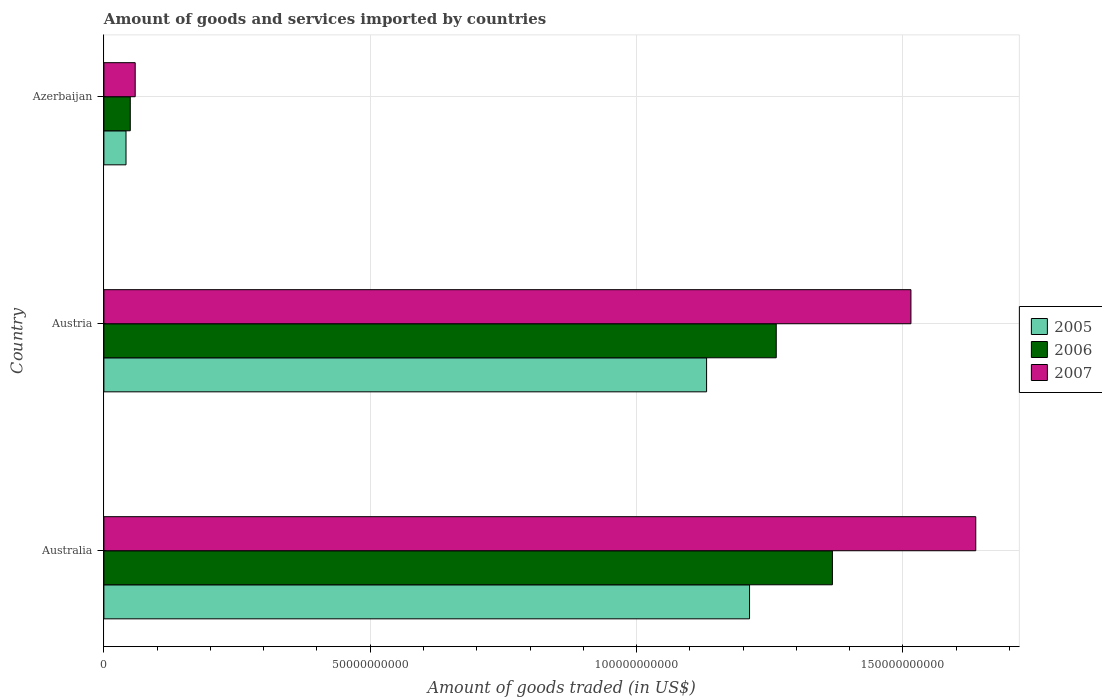How many different coloured bars are there?
Provide a short and direct response. 3. Are the number of bars per tick equal to the number of legend labels?
Make the answer very short. Yes. Are the number of bars on each tick of the Y-axis equal?
Provide a succinct answer. Yes. How many bars are there on the 3rd tick from the top?
Your answer should be compact. 3. What is the label of the 1st group of bars from the top?
Make the answer very short. Azerbaijan. What is the total amount of goods and services imported in 2007 in Australia?
Provide a succinct answer. 1.64e+11. Across all countries, what is the maximum total amount of goods and services imported in 2005?
Make the answer very short. 1.21e+11. Across all countries, what is the minimum total amount of goods and services imported in 2007?
Your answer should be compact. 5.88e+09. In which country was the total amount of goods and services imported in 2005 minimum?
Your answer should be compact. Azerbaijan. What is the total total amount of goods and services imported in 2005 in the graph?
Ensure brevity in your answer.  2.39e+11. What is the difference between the total amount of goods and services imported in 2007 in Austria and that in Azerbaijan?
Offer a very short reply. 1.46e+11. What is the difference between the total amount of goods and services imported in 2006 in Azerbaijan and the total amount of goods and services imported in 2005 in Austria?
Make the answer very short. -1.08e+11. What is the average total amount of goods and services imported in 2005 per country?
Provide a succinct answer. 7.95e+1. What is the difference between the total amount of goods and services imported in 2006 and total amount of goods and services imported in 2005 in Austria?
Ensure brevity in your answer.  1.31e+1. In how many countries, is the total amount of goods and services imported in 2005 greater than 110000000000 US$?
Keep it short and to the point. 2. What is the ratio of the total amount of goods and services imported in 2005 in Austria to that in Azerbaijan?
Your answer should be compact. 27.25. Is the total amount of goods and services imported in 2005 in Austria less than that in Azerbaijan?
Offer a terse response. No. Is the difference between the total amount of goods and services imported in 2006 in Austria and Azerbaijan greater than the difference between the total amount of goods and services imported in 2005 in Austria and Azerbaijan?
Your answer should be compact. Yes. What is the difference between the highest and the second highest total amount of goods and services imported in 2005?
Make the answer very short. 8.06e+09. What is the difference between the highest and the lowest total amount of goods and services imported in 2005?
Offer a terse response. 1.17e+11. Is the sum of the total amount of goods and services imported in 2005 in Austria and Azerbaijan greater than the maximum total amount of goods and services imported in 2006 across all countries?
Give a very brief answer. No. What does the 2nd bar from the bottom in Australia represents?
Give a very brief answer. 2006. Is it the case that in every country, the sum of the total amount of goods and services imported in 2006 and total amount of goods and services imported in 2005 is greater than the total amount of goods and services imported in 2007?
Provide a succinct answer. Yes. How many countries are there in the graph?
Provide a short and direct response. 3. What is the difference between two consecutive major ticks on the X-axis?
Keep it short and to the point. 5.00e+1. Does the graph contain any zero values?
Give a very brief answer. No. Does the graph contain grids?
Your answer should be very brief. Yes. Where does the legend appear in the graph?
Your response must be concise. Center right. How many legend labels are there?
Provide a short and direct response. 3. What is the title of the graph?
Your answer should be very brief. Amount of goods and services imported by countries. Does "1976" appear as one of the legend labels in the graph?
Your answer should be compact. No. What is the label or title of the X-axis?
Offer a very short reply. Amount of goods traded (in US$). What is the Amount of goods traded (in US$) in 2005 in Australia?
Give a very brief answer. 1.21e+11. What is the Amount of goods traded (in US$) in 2006 in Australia?
Offer a very short reply. 1.37e+11. What is the Amount of goods traded (in US$) in 2007 in Australia?
Your answer should be very brief. 1.64e+11. What is the Amount of goods traded (in US$) of 2005 in Austria?
Make the answer very short. 1.13e+11. What is the Amount of goods traded (in US$) in 2006 in Austria?
Your response must be concise. 1.26e+11. What is the Amount of goods traded (in US$) of 2007 in Austria?
Your response must be concise. 1.52e+11. What is the Amount of goods traded (in US$) in 2005 in Azerbaijan?
Make the answer very short. 4.15e+09. What is the Amount of goods traded (in US$) in 2006 in Azerbaijan?
Give a very brief answer. 4.95e+09. What is the Amount of goods traded (in US$) of 2007 in Azerbaijan?
Offer a very short reply. 5.88e+09. Across all countries, what is the maximum Amount of goods traded (in US$) in 2005?
Offer a terse response. 1.21e+11. Across all countries, what is the maximum Amount of goods traded (in US$) of 2006?
Ensure brevity in your answer.  1.37e+11. Across all countries, what is the maximum Amount of goods traded (in US$) of 2007?
Offer a very short reply. 1.64e+11. Across all countries, what is the minimum Amount of goods traded (in US$) in 2005?
Offer a very short reply. 4.15e+09. Across all countries, what is the minimum Amount of goods traded (in US$) of 2006?
Make the answer very short. 4.95e+09. Across all countries, what is the minimum Amount of goods traded (in US$) of 2007?
Offer a terse response. 5.88e+09. What is the total Amount of goods traded (in US$) of 2005 in the graph?
Provide a succinct answer. 2.39e+11. What is the total Amount of goods traded (in US$) of 2006 in the graph?
Your response must be concise. 2.68e+11. What is the total Amount of goods traded (in US$) in 2007 in the graph?
Provide a succinct answer. 3.21e+11. What is the difference between the Amount of goods traded (in US$) in 2005 in Australia and that in Austria?
Keep it short and to the point. 8.06e+09. What is the difference between the Amount of goods traded (in US$) in 2006 in Australia and that in Austria?
Your response must be concise. 1.05e+1. What is the difference between the Amount of goods traded (in US$) of 2007 in Australia and that in Austria?
Your answer should be very brief. 1.22e+1. What is the difference between the Amount of goods traded (in US$) of 2005 in Australia and that in Azerbaijan?
Provide a succinct answer. 1.17e+11. What is the difference between the Amount of goods traded (in US$) of 2006 in Australia and that in Azerbaijan?
Keep it short and to the point. 1.32e+11. What is the difference between the Amount of goods traded (in US$) of 2007 in Australia and that in Azerbaijan?
Offer a terse response. 1.58e+11. What is the difference between the Amount of goods traded (in US$) of 2005 in Austria and that in Azerbaijan?
Your response must be concise. 1.09e+11. What is the difference between the Amount of goods traded (in US$) of 2006 in Austria and that in Azerbaijan?
Offer a very short reply. 1.21e+11. What is the difference between the Amount of goods traded (in US$) in 2007 in Austria and that in Azerbaijan?
Keep it short and to the point. 1.46e+11. What is the difference between the Amount of goods traded (in US$) in 2005 in Australia and the Amount of goods traded (in US$) in 2006 in Austria?
Offer a very short reply. -5.01e+09. What is the difference between the Amount of goods traded (in US$) in 2005 in Australia and the Amount of goods traded (in US$) in 2007 in Austria?
Keep it short and to the point. -3.03e+1. What is the difference between the Amount of goods traded (in US$) in 2006 in Australia and the Amount of goods traded (in US$) in 2007 in Austria?
Your answer should be very brief. -1.47e+1. What is the difference between the Amount of goods traded (in US$) of 2005 in Australia and the Amount of goods traded (in US$) of 2006 in Azerbaijan?
Offer a terse response. 1.16e+11. What is the difference between the Amount of goods traded (in US$) of 2005 in Australia and the Amount of goods traded (in US$) of 2007 in Azerbaijan?
Your response must be concise. 1.15e+11. What is the difference between the Amount of goods traded (in US$) of 2006 in Australia and the Amount of goods traded (in US$) of 2007 in Azerbaijan?
Your answer should be compact. 1.31e+11. What is the difference between the Amount of goods traded (in US$) in 2005 in Austria and the Amount of goods traded (in US$) in 2006 in Azerbaijan?
Your answer should be very brief. 1.08e+11. What is the difference between the Amount of goods traded (in US$) of 2005 in Austria and the Amount of goods traded (in US$) of 2007 in Azerbaijan?
Provide a short and direct response. 1.07e+11. What is the difference between the Amount of goods traded (in US$) in 2006 in Austria and the Amount of goods traded (in US$) in 2007 in Azerbaijan?
Offer a very short reply. 1.20e+11. What is the average Amount of goods traded (in US$) of 2005 per country?
Give a very brief answer. 7.95e+1. What is the average Amount of goods traded (in US$) in 2006 per country?
Offer a very short reply. 8.93e+1. What is the average Amount of goods traded (in US$) in 2007 per country?
Your answer should be very brief. 1.07e+11. What is the difference between the Amount of goods traded (in US$) of 2005 and Amount of goods traded (in US$) of 2006 in Australia?
Your response must be concise. -1.56e+1. What is the difference between the Amount of goods traded (in US$) of 2005 and Amount of goods traded (in US$) of 2007 in Australia?
Give a very brief answer. -4.25e+1. What is the difference between the Amount of goods traded (in US$) of 2006 and Amount of goods traded (in US$) of 2007 in Australia?
Provide a short and direct response. -2.69e+1. What is the difference between the Amount of goods traded (in US$) of 2005 and Amount of goods traded (in US$) of 2006 in Austria?
Give a very brief answer. -1.31e+1. What is the difference between the Amount of goods traded (in US$) of 2005 and Amount of goods traded (in US$) of 2007 in Austria?
Your response must be concise. -3.84e+1. What is the difference between the Amount of goods traded (in US$) of 2006 and Amount of goods traded (in US$) of 2007 in Austria?
Give a very brief answer. -2.53e+1. What is the difference between the Amount of goods traded (in US$) in 2005 and Amount of goods traded (in US$) in 2006 in Azerbaijan?
Your answer should be very brief. -8.02e+08. What is the difference between the Amount of goods traded (in US$) in 2005 and Amount of goods traded (in US$) in 2007 in Azerbaijan?
Offer a very short reply. -1.73e+09. What is the difference between the Amount of goods traded (in US$) in 2006 and Amount of goods traded (in US$) in 2007 in Azerbaijan?
Keep it short and to the point. -9.23e+08. What is the ratio of the Amount of goods traded (in US$) in 2005 in Australia to that in Austria?
Your response must be concise. 1.07. What is the ratio of the Amount of goods traded (in US$) in 2006 in Australia to that in Austria?
Keep it short and to the point. 1.08. What is the ratio of the Amount of goods traded (in US$) in 2007 in Australia to that in Austria?
Ensure brevity in your answer.  1.08. What is the ratio of the Amount of goods traded (in US$) of 2005 in Australia to that in Azerbaijan?
Give a very brief answer. 29.19. What is the ratio of the Amount of goods traded (in US$) of 2006 in Australia to that in Azerbaijan?
Give a very brief answer. 27.61. What is the ratio of the Amount of goods traded (in US$) in 2007 in Australia to that in Azerbaijan?
Your answer should be compact. 27.85. What is the ratio of the Amount of goods traded (in US$) in 2005 in Austria to that in Azerbaijan?
Ensure brevity in your answer.  27.25. What is the ratio of the Amount of goods traded (in US$) of 2006 in Austria to that in Azerbaijan?
Keep it short and to the point. 25.48. What is the ratio of the Amount of goods traded (in US$) of 2007 in Austria to that in Azerbaijan?
Your response must be concise. 25.78. What is the difference between the highest and the second highest Amount of goods traded (in US$) in 2005?
Provide a succinct answer. 8.06e+09. What is the difference between the highest and the second highest Amount of goods traded (in US$) in 2006?
Your response must be concise. 1.05e+1. What is the difference between the highest and the second highest Amount of goods traded (in US$) in 2007?
Keep it short and to the point. 1.22e+1. What is the difference between the highest and the lowest Amount of goods traded (in US$) of 2005?
Offer a terse response. 1.17e+11. What is the difference between the highest and the lowest Amount of goods traded (in US$) in 2006?
Your answer should be very brief. 1.32e+11. What is the difference between the highest and the lowest Amount of goods traded (in US$) in 2007?
Your answer should be compact. 1.58e+11. 